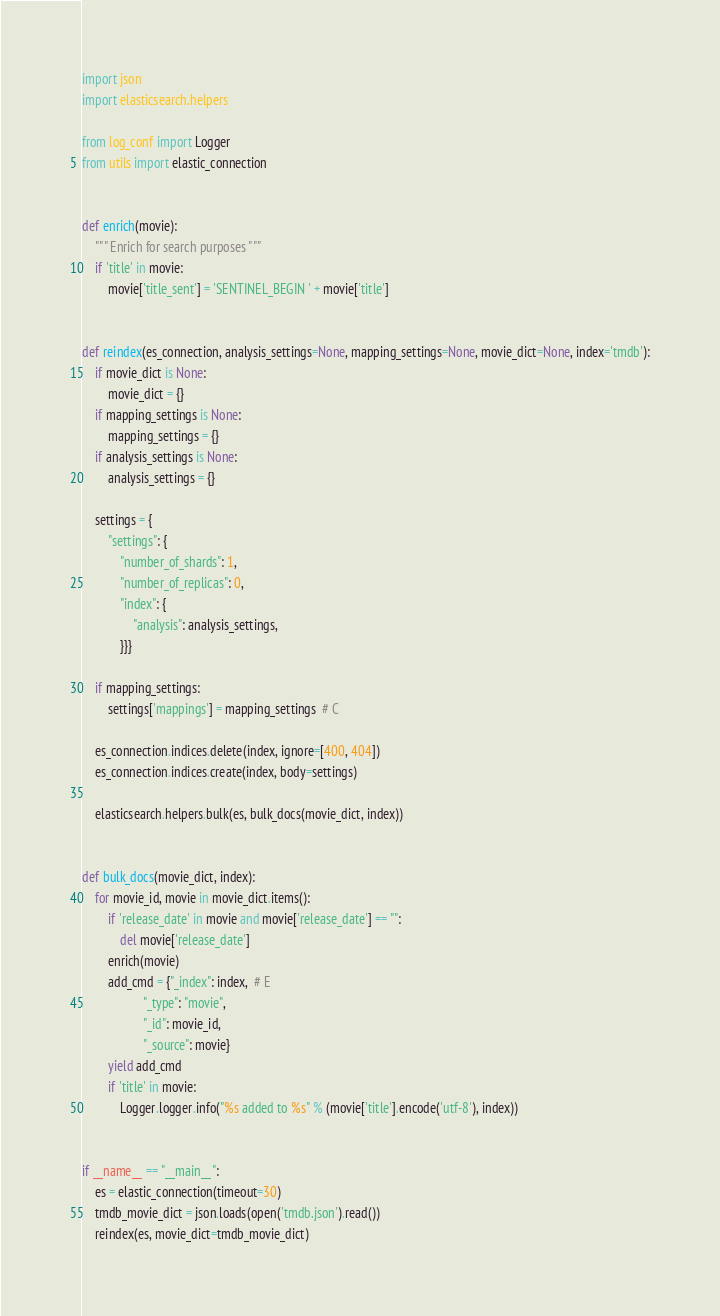<code> <loc_0><loc_0><loc_500><loc_500><_Python_>import json
import elasticsearch.helpers

from log_conf import Logger
from utils import elastic_connection


def enrich(movie):
    """ Enrich for search purposes """
    if 'title' in movie:
        movie['title_sent'] = 'SENTINEL_BEGIN ' + movie['title']


def reindex(es_connection, analysis_settings=None, mapping_settings=None, movie_dict=None, index='tmdb'):
    if movie_dict is None:
        movie_dict = {}
    if mapping_settings is None:
        mapping_settings = {}
    if analysis_settings is None:
        analysis_settings = {}

    settings = {
        "settings": {
            "number_of_shards": 1,
            "number_of_replicas": 0,
            "index": {
                "analysis": analysis_settings,
            }}}

    if mapping_settings:
        settings['mappings'] = mapping_settings  # C

    es_connection.indices.delete(index, ignore=[400, 404])
    es_connection.indices.create(index, body=settings)

    elasticsearch.helpers.bulk(es, bulk_docs(movie_dict, index))


def bulk_docs(movie_dict, index):
    for movie_id, movie in movie_dict.items():
        if 'release_date' in movie and movie['release_date'] == "":
            del movie['release_date']
        enrich(movie)
        add_cmd = {"_index": index,  # E
                   "_type": "movie",
                   "_id": movie_id,
                   "_source": movie}
        yield add_cmd
        if 'title' in movie:
            Logger.logger.info("%s added to %s" % (movie['title'].encode('utf-8'), index))


if __name__ == "__main__":
    es = elastic_connection(timeout=30)
    tmdb_movie_dict = json.loads(open('tmdb.json').read())
    reindex(es, movie_dict=tmdb_movie_dict)
</code> 